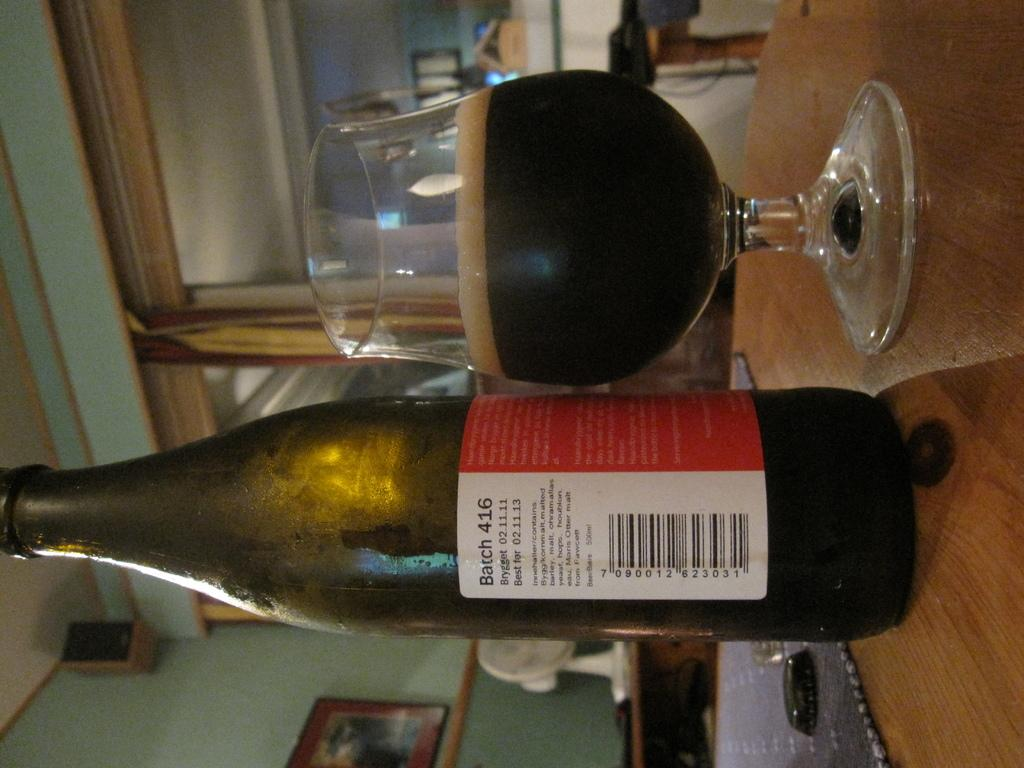<image>
Write a terse but informative summary of the picture. A beer bottle that says Barch 416 placed next to a beer glass. 